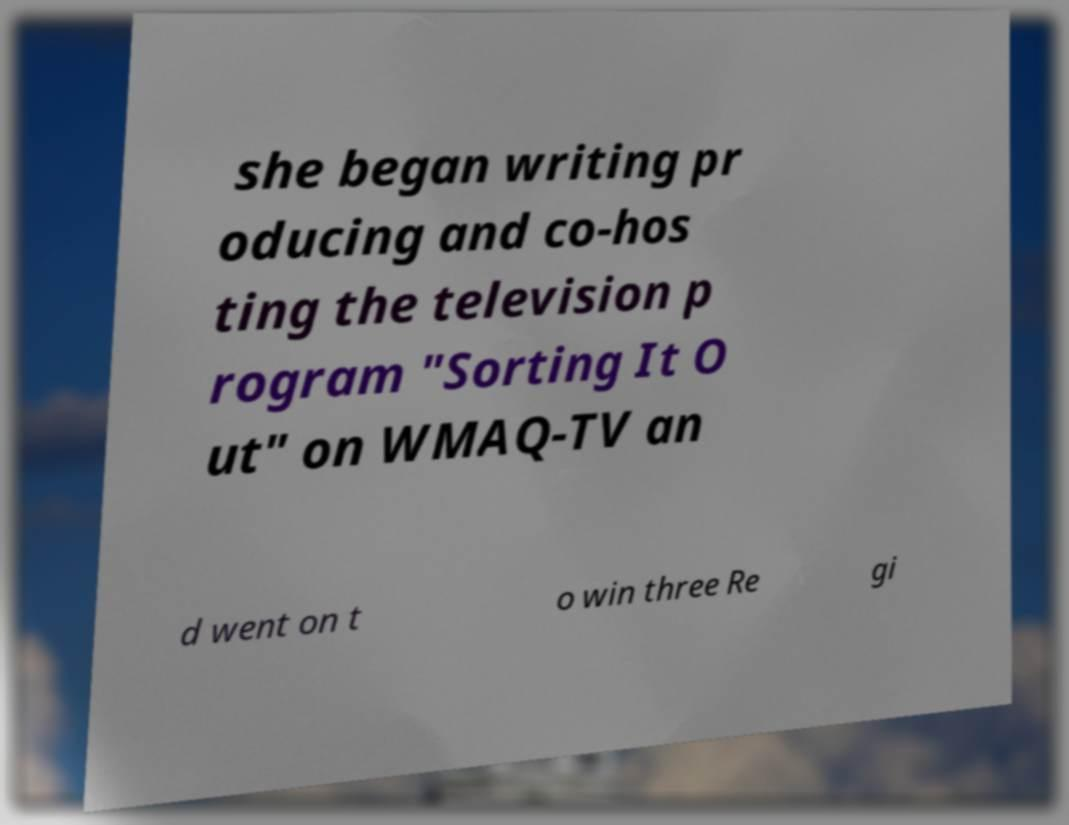There's text embedded in this image that I need extracted. Can you transcribe it verbatim? she began writing pr oducing and co-hos ting the television p rogram "Sorting It O ut" on WMAQ-TV an d went on t o win three Re gi 